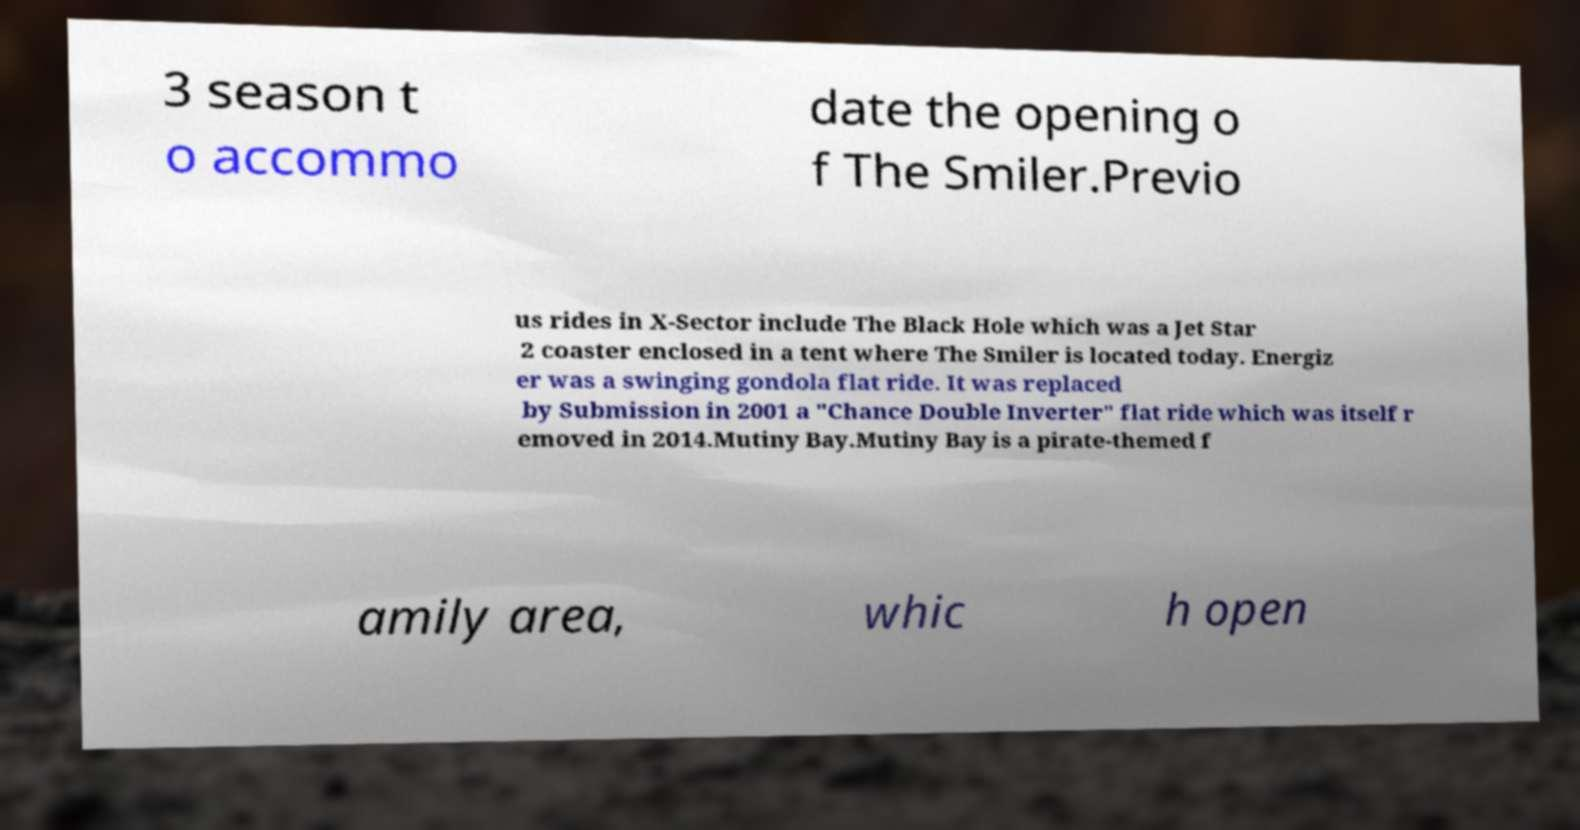I need the written content from this picture converted into text. Can you do that? 3 season t o accommo date the opening o f The Smiler.Previo us rides in X-Sector include The Black Hole which was a Jet Star 2 coaster enclosed in a tent where The Smiler is located today. Energiz er was a swinging gondola flat ride. It was replaced by Submission in 2001 a "Chance Double Inverter" flat ride which was itself r emoved in 2014.Mutiny Bay.Mutiny Bay is a pirate-themed f amily area, whic h open 